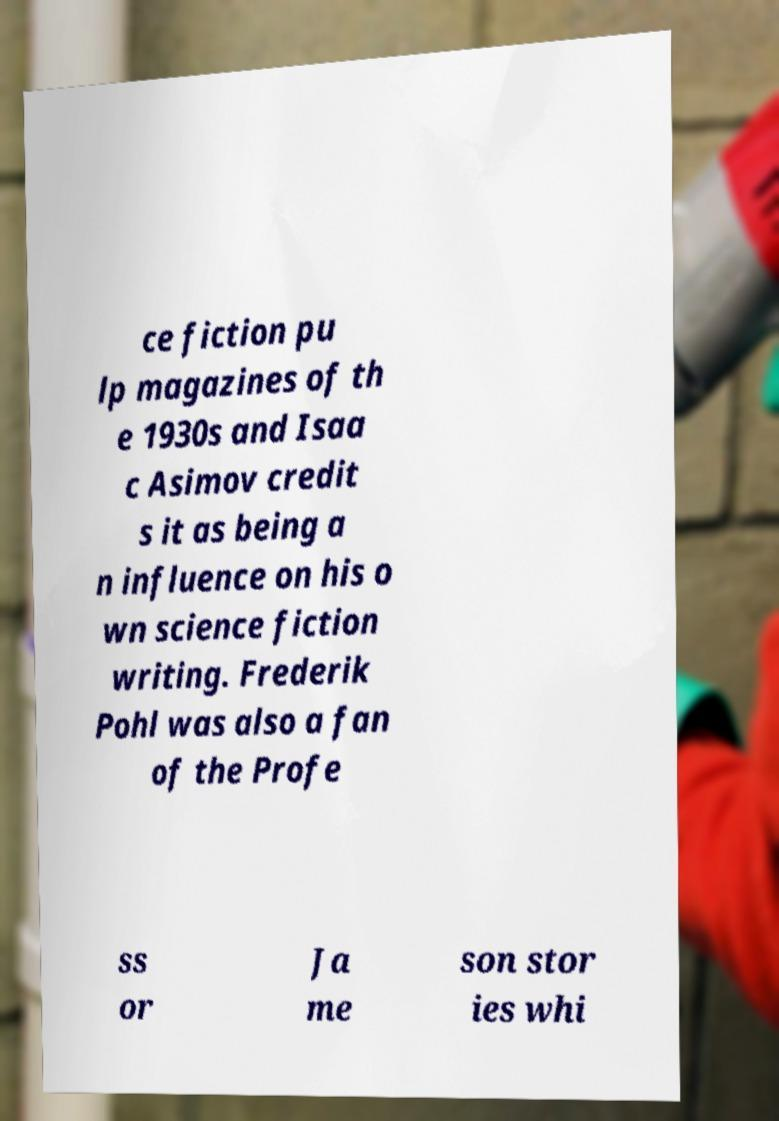Please identify and transcribe the text found in this image. ce fiction pu lp magazines of th e 1930s and Isaa c Asimov credit s it as being a n influence on his o wn science fiction writing. Frederik Pohl was also a fan of the Profe ss or Ja me son stor ies whi 